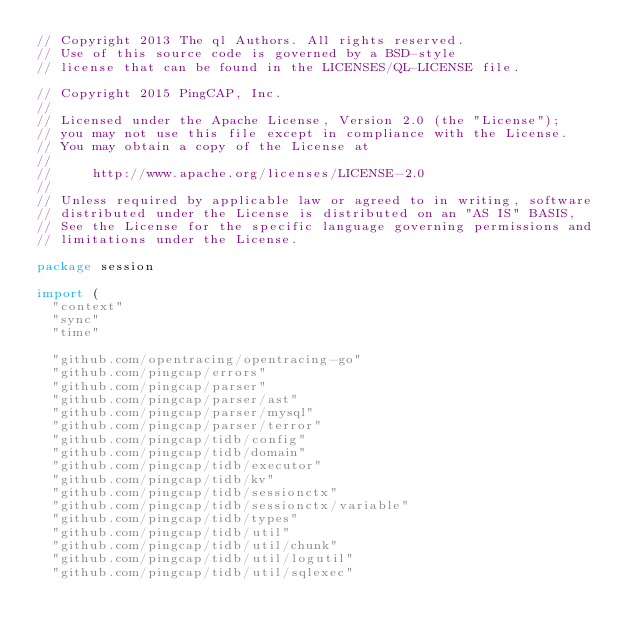Convert code to text. <code><loc_0><loc_0><loc_500><loc_500><_Go_>// Copyright 2013 The ql Authors. All rights reserved.
// Use of this source code is governed by a BSD-style
// license that can be found in the LICENSES/QL-LICENSE file.

// Copyright 2015 PingCAP, Inc.
//
// Licensed under the Apache License, Version 2.0 (the "License");
// you may not use this file except in compliance with the License.
// You may obtain a copy of the License at
//
//     http://www.apache.org/licenses/LICENSE-2.0
//
// Unless required by applicable law or agreed to in writing, software
// distributed under the License is distributed on an "AS IS" BASIS,
// See the License for the specific language governing permissions and
// limitations under the License.

package session

import (
	"context"
	"sync"
	"time"

	"github.com/opentracing/opentracing-go"
	"github.com/pingcap/errors"
	"github.com/pingcap/parser"
	"github.com/pingcap/parser/ast"
	"github.com/pingcap/parser/mysql"
	"github.com/pingcap/parser/terror"
	"github.com/pingcap/tidb/config"
	"github.com/pingcap/tidb/domain"
	"github.com/pingcap/tidb/executor"
	"github.com/pingcap/tidb/kv"
	"github.com/pingcap/tidb/sessionctx"
	"github.com/pingcap/tidb/sessionctx/variable"
	"github.com/pingcap/tidb/types"
	"github.com/pingcap/tidb/util"
	"github.com/pingcap/tidb/util/chunk"
	"github.com/pingcap/tidb/util/logutil"
	"github.com/pingcap/tidb/util/sqlexec"</code> 